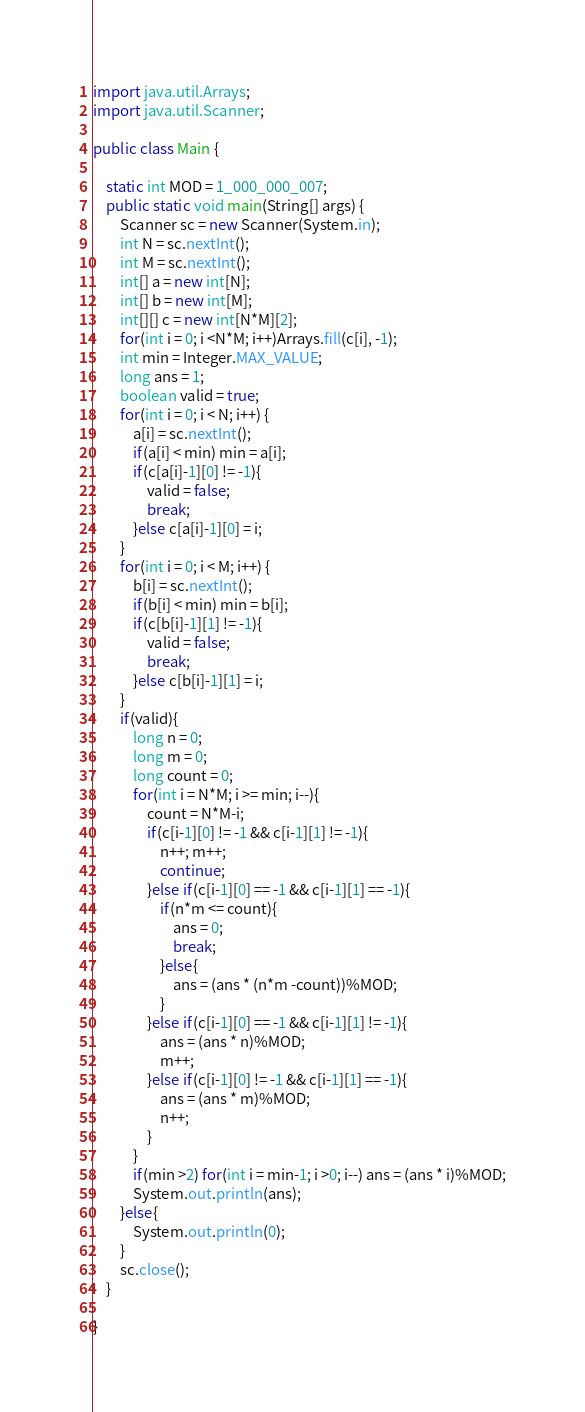Convert code to text. <code><loc_0><loc_0><loc_500><loc_500><_Java_>import java.util.Arrays;
import java.util.Scanner;

public class Main {

    static int MOD = 1_000_000_007;
    public static void main(String[] args) {
        Scanner sc = new Scanner(System.in);
        int N = sc.nextInt();
        int M = sc.nextInt();
        int[] a = new int[N];
        int[] b = new int[M];
        int[][] c = new int[N*M][2];
        for(int i = 0; i <N*M; i++)Arrays.fill(c[i], -1);
        int min = Integer.MAX_VALUE;
        long ans = 1;
        boolean valid = true;
        for(int i = 0; i < N; i++) {
            a[i] = sc.nextInt();
            if(a[i] < min) min = a[i];
            if(c[a[i]-1][0] != -1){
                valid = false;
                break;
            }else c[a[i]-1][0] = i;
        }
        for(int i = 0; i < M; i++) {
            b[i] = sc.nextInt();
            if(b[i] < min) min = b[i];
            if(c[b[i]-1][1] != -1){
                valid = false;
                break;
            }else c[b[i]-1][1] = i;
        }
        if(valid){
            long n = 0;
            long m = 0;
            long count = 0;
            for(int i = N*M; i >= min; i--){
                count = N*M-i;
                if(c[i-1][0] != -1 && c[i-1][1] != -1){
                    n++; m++;
                    continue;
                }else if(c[i-1][0] == -1 && c[i-1][1] == -1){
                    if(n*m <= count){
                        ans = 0;
                        break;
                    }else{
                        ans = (ans * (n*m -count))%MOD;
                    }
                }else if(c[i-1][0] == -1 && c[i-1][1] != -1){
                    ans = (ans * n)%MOD;
                    m++;
                }else if(c[i-1][0] != -1 && c[i-1][1] == -1){
                    ans = (ans * m)%MOD;
                    n++;
                }
            }
            if(min >2) for(int i = min-1; i >0; i--) ans = (ans * i)%MOD;
            System.out.println(ans);
        }else{
            System.out.println(0);
        }
        sc.close();
    }

}
</code> 